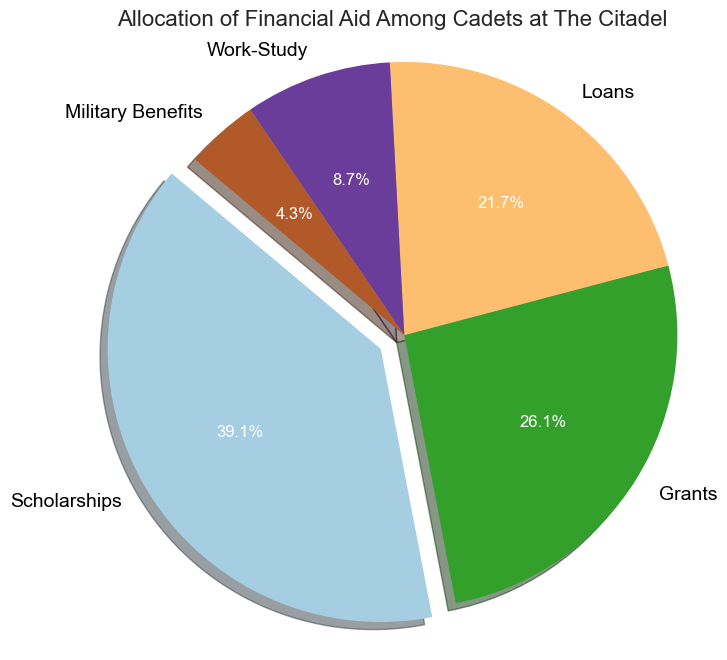What percentage of the total financial aid is given as scholarships? By looking at the pie chart, identify the wedge labeled 'Scholarships' and its corresponding percentage to determine how much of the total financial aid is allocated as scholarships.
Answer: 45.0% Is the amount of aid provided through loans more or less than the amount given through grants? Compare the size and percentage labels of the wedges representing 'Loans' and 'Grants'. If the 'Loans' wedge is smaller and has a lower percentage than 'Grants', then loans are less; otherwise, they are more.
Answer: Less What combined percentage do Scholarships and Grants account for in the financial aid distribution? Add the percentages of the wedges labeled 'Scholarships' and 'Grants'. For Scholarships, it's 45.0%, and for Grants, it's 30.0%. Combining these gives 45.0% + 30.0% = 75.0%.
Answer: 75.0% Which financial aid type is the smallest in terms of allocation? Look at the pie chart and identify the smallest wedge or the one with the smallest percentage. The label on this wedge indicates the type of aid.
Answer: Military Benefits How does the allocation of Work-Study compare to Military Benefits in terms of percentage? Observe the wedges labeled 'Work-Study' and 'Military Benefits'. Note the percentages; Work-Study is 10.0%, and Military Benefits is 5.0%. Compare these to see that Work-Study is larger.
Answer: Work-Study is higher If the total financial aid budget increased by $1,000,000 equally distributed among all categories, how much would each category increase? There are 5 categories: Scholarships, Grants, Loans, Work-Study, and Military Benefits. Dividing the $1,000,000 increase equally gives $1,000,000 / 5 = $200,000 per category.
Answer: $200,000 each By what percentage does the aid provided through loans lag behind that provided through scholarships? Subtract the percentage of 'Loans' (25.0%) from 'Scholarships' (45.0%). This results in 45.0% - 25.0%, equating to a 20.0% lag.
Answer: 20.0% What is the total amount of financial aid distributed to cadets at The Citadel? Sum all the individual amounts given for Scholarships, Grants, Loans, Work-Study, and Military Benefits. 4,500,000 + 3,000,000 + 2,500,000 + 1,000,000 + 500,000 = 11,500,000.
Answer: $11,500,000 